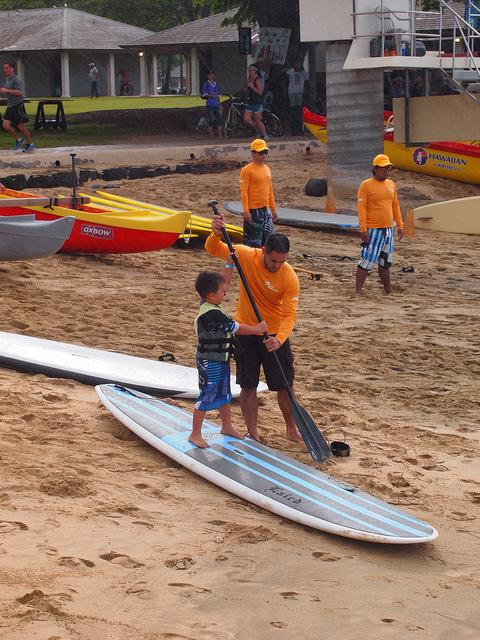The small person here learns how to do what? surf 